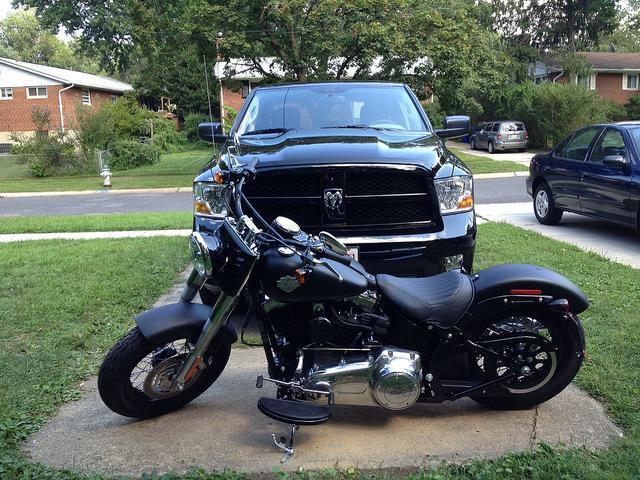How many red motorcycles?
Give a very brief answer. 0. How many people have glasses on their sitting on their heads?
Give a very brief answer. 0. 